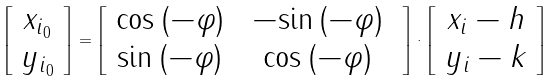<formula> <loc_0><loc_0><loc_500><loc_500>\left [ \begin{array} { c } x _ { i _ { 0 } } \\ y _ { i _ { 0 } } \end{array} \right ] = \left [ \begin{array} { c c } { \cos \left ( - \varphi \right ) \ } & - { \sin \left ( - \varphi \right ) \ } \\ { \sin \left ( - \varphi \right ) \ } & { \cos \left ( - \varphi \right ) \ } \end{array} \right ] \cdot \left [ \begin{array} { c } x _ { i } - h \\ y _ { i } - k \end{array} \right ]</formula> 